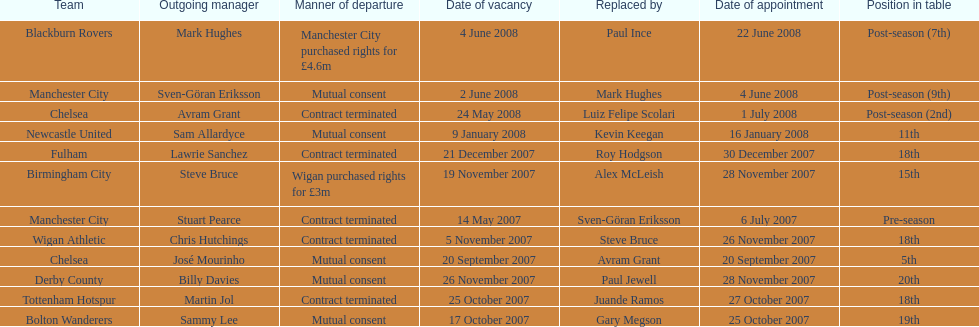Avram grant was with chelsea for at least how many years? 1. 